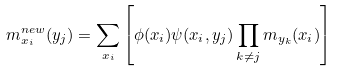<formula> <loc_0><loc_0><loc_500><loc_500>m _ { x _ { i } } ^ { n e w } ( y _ { j } ) = \sum _ { x _ { i } } \left [ \phi ( x _ { i } ) \psi ( x _ { i } , y _ { j } ) \prod _ { k \neq j } m _ { y _ { k } } ( x _ { i } ) \right ]</formula> 